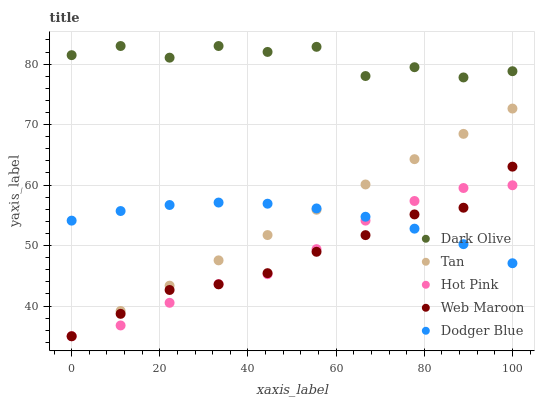Does Web Maroon have the minimum area under the curve?
Answer yes or no. Yes. Does Dark Olive have the maximum area under the curve?
Answer yes or no. Yes. Does Tan have the minimum area under the curve?
Answer yes or no. No. Does Tan have the maximum area under the curve?
Answer yes or no. No. Is Tan the smoothest?
Answer yes or no. Yes. Is Dark Olive the roughest?
Answer yes or no. Yes. Is Dark Olive the smoothest?
Answer yes or no. No. Is Tan the roughest?
Answer yes or no. No. Does Tan have the lowest value?
Answer yes or no. Yes. Does Dark Olive have the lowest value?
Answer yes or no. No. Does Dark Olive have the highest value?
Answer yes or no. Yes. Does Tan have the highest value?
Answer yes or no. No. Is Tan less than Dark Olive?
Answer yes or no. Yes. Is Dark Olive greater than Web Maroon?
Answer yes or no. Yes. Does Hot Pink intersect Dodger Blue?
Answer yes or no. Yes. Is Hot Pink less than Dodger Blue?
Answer yes or no. No. Is Hot Pink greater than Dodger Blue?
Answer yes or no. No. Does Tan intersect Dark Olive?
Answer yes or no. No. 